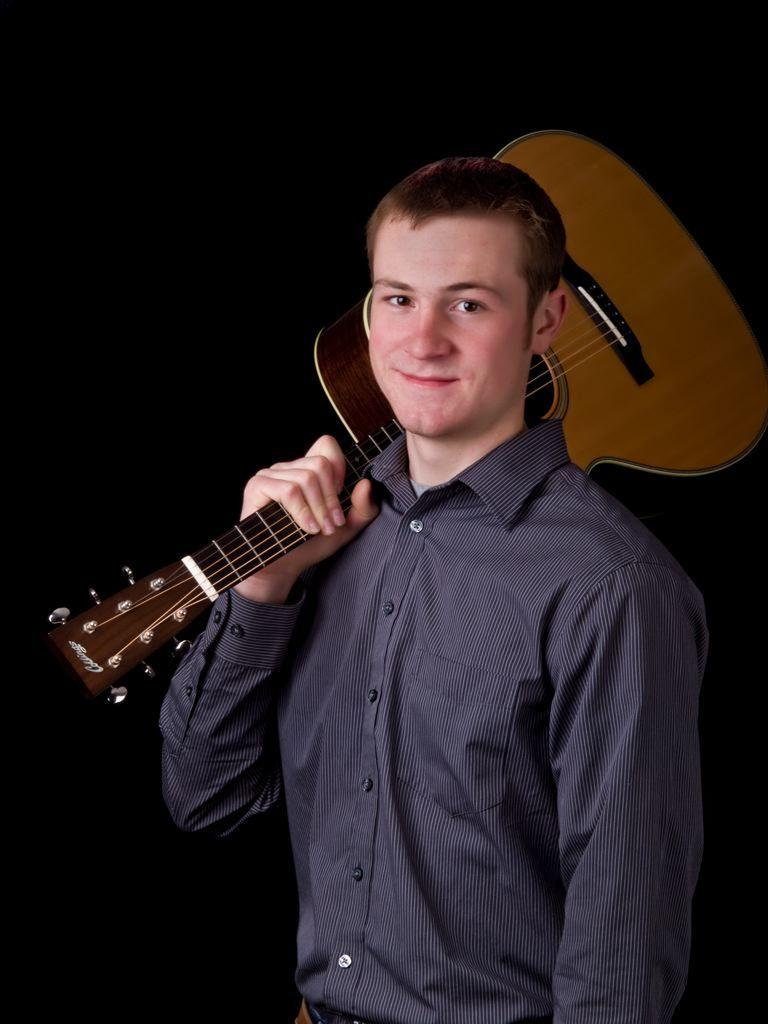What is the man in the image holding? The man is holding a guitar. What is the man's facial expression in the image? The man is smiling. What type of clothing is the man wearing in the image? The man is wearing a shirt. What color is the shirt the man is wearing? The shirt is black in color. Why is the man crying in the image? The man is not crying in the image; he is smiling. What type of cheese is present in the image? There is no cheese present in the image. 